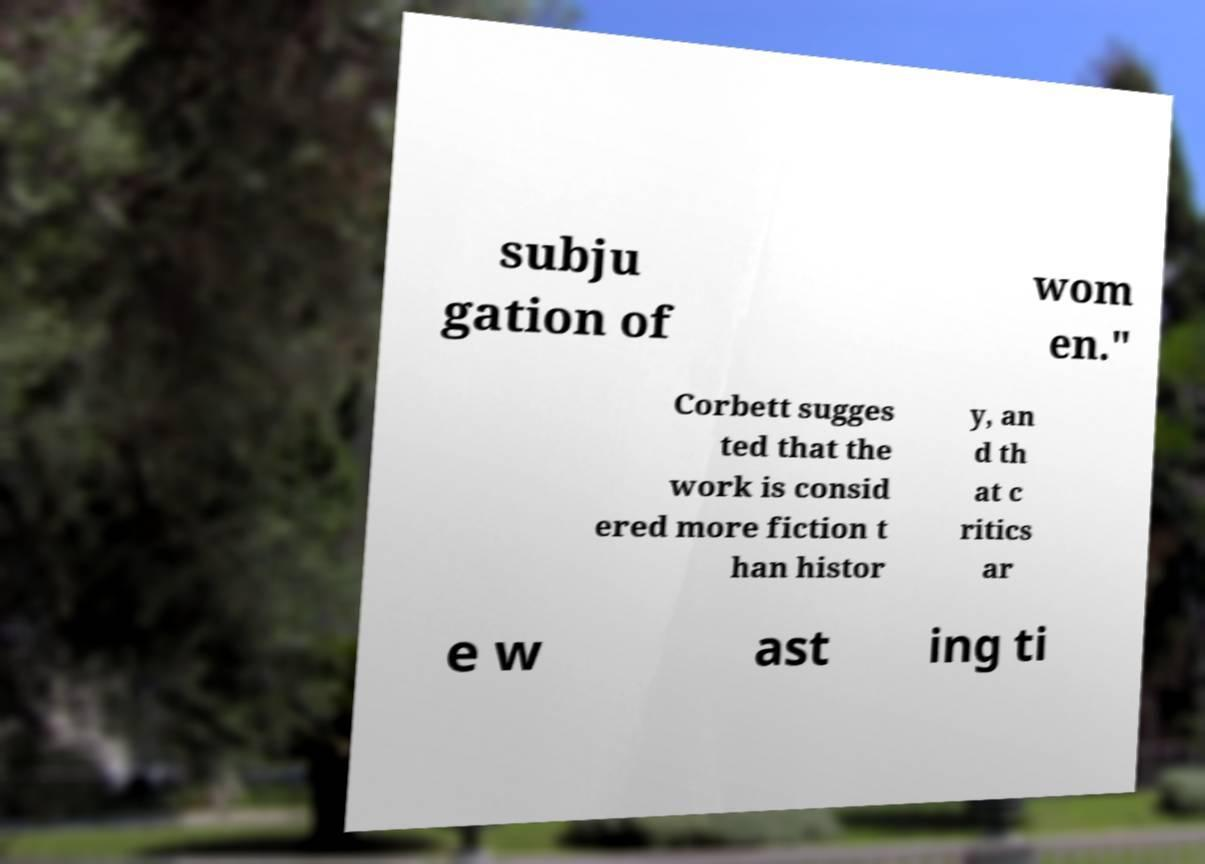Please read and relay the text visible in this image. What does it say? subju gation of wom en." Corbett sugges ted that the work is consid ered more fiction t han histor y, an d th at c ritics ar e w ast ing ti 